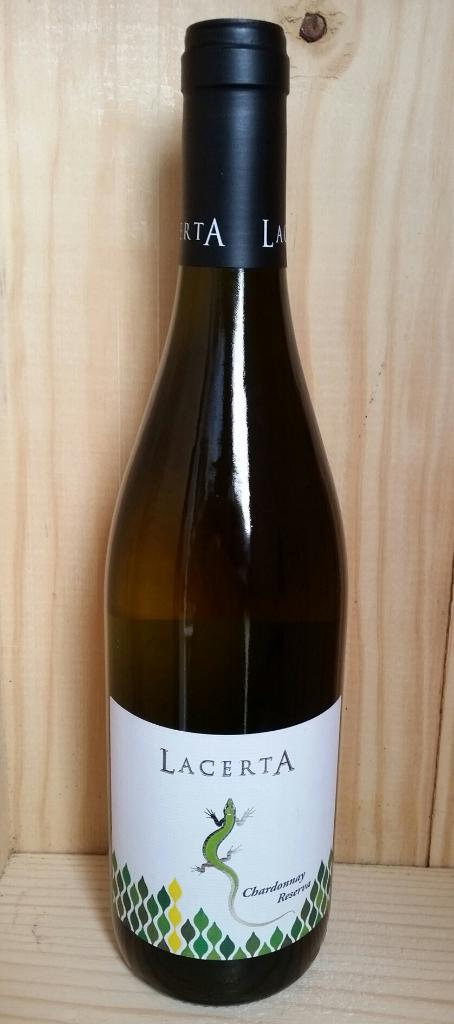Provide a one-sentence caption for the provided image. Bottle of Lacerta wine that is brand new. 